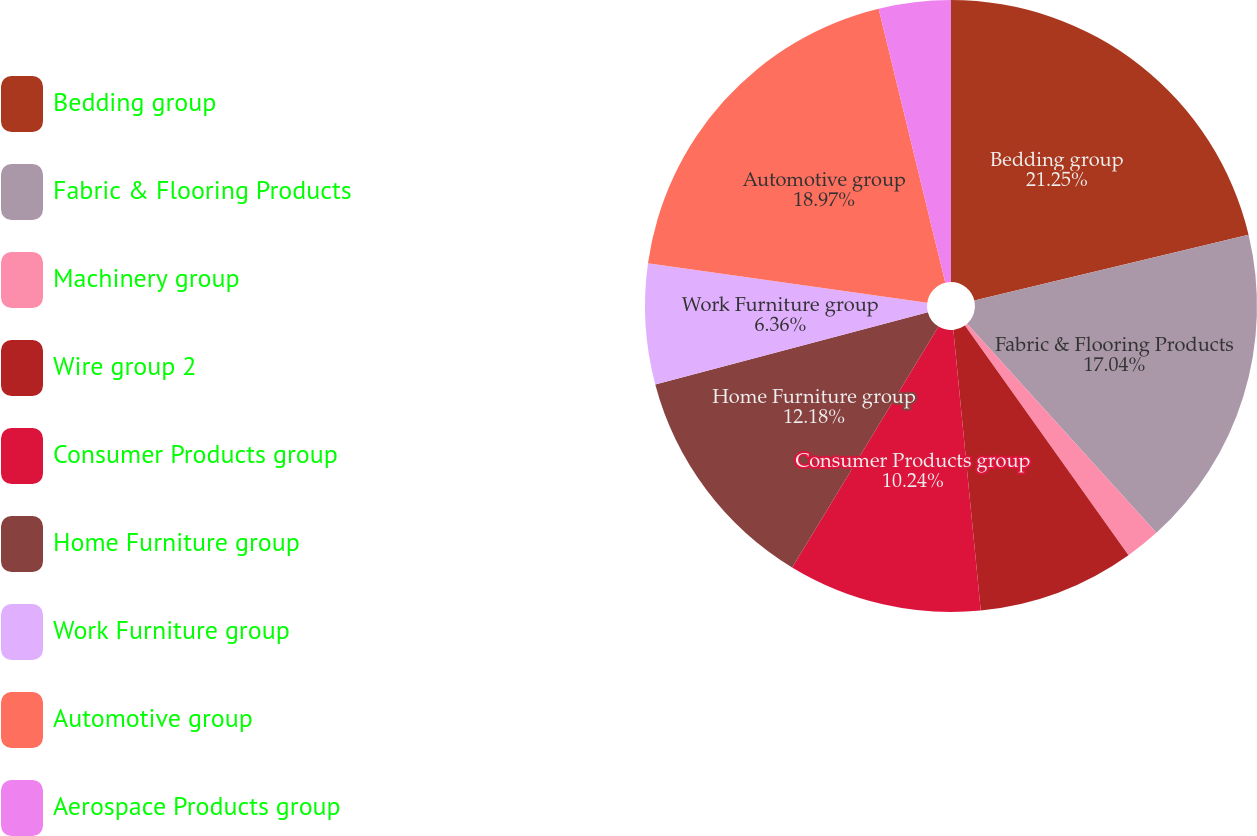Convert chart. <chart><loc_0><loc_0><loc_500><loc_500><pie_chart><fcel>Bedding group<fcel>Fabric & Flooring Products<fcel>Machinery group<fcel>Wire group 2<fcel>Consumer Products group<fcel>Home Furniture group<fcel>Work Furniture group<fcel>Automotive group<fcel>Aerospace Products group<nl><fcel>21.26%<fcel>17.04%<fcel>1.86%<fcel>8.3%<fcel>10.24%<fcel>12.18%<fcel>6.36%<fcel>18.98%<fcel>3.8%<nl></chart> 